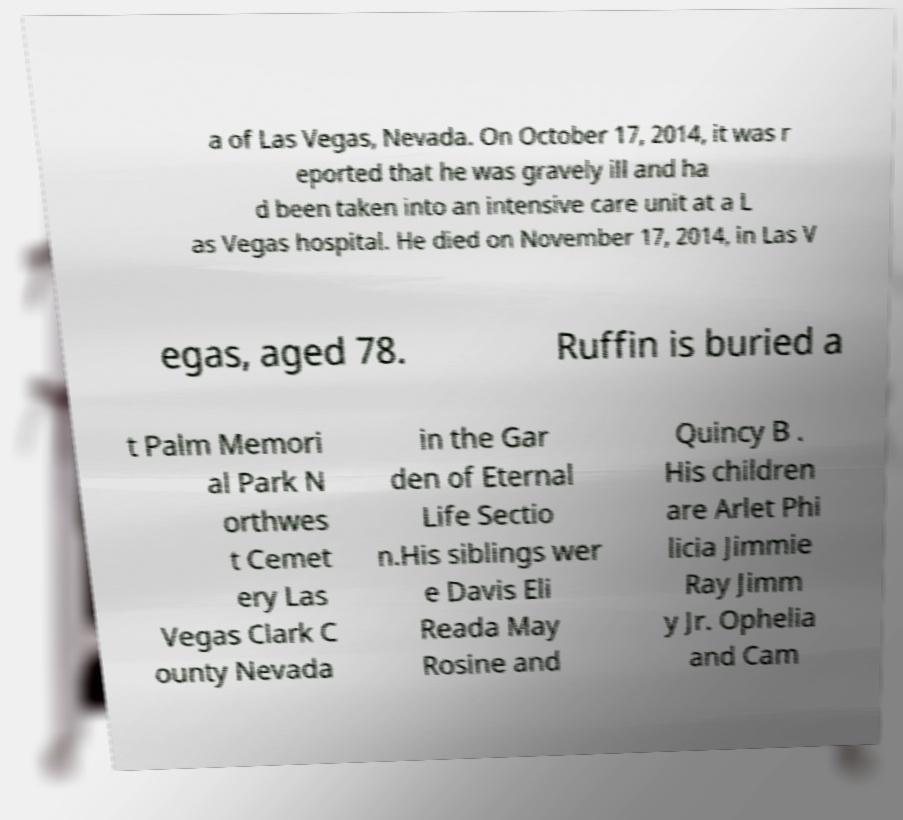I need the written content from this picture converted into text. Can you do that? a of Las Vegas, Nevada. On October 17, 2014, it was r eported that he was gravely ill and ha d been taken into an intensive care unit at a L as Vegas hospital. He died on November 17, 2014, in Las V egas, aged 78. Ruffin is buried a t Palm Memori al Park N orthwes t Cemet ery Las Vegas Clark C ounty Nevada in the Gar den of Eternal Life Sectio n.His siblings wer e Davis Eli Reada May Rosine and Quincy B . His children are Arlet Phi licia Jimmie Ray Jimm y Jr. Ophelia and Cam 